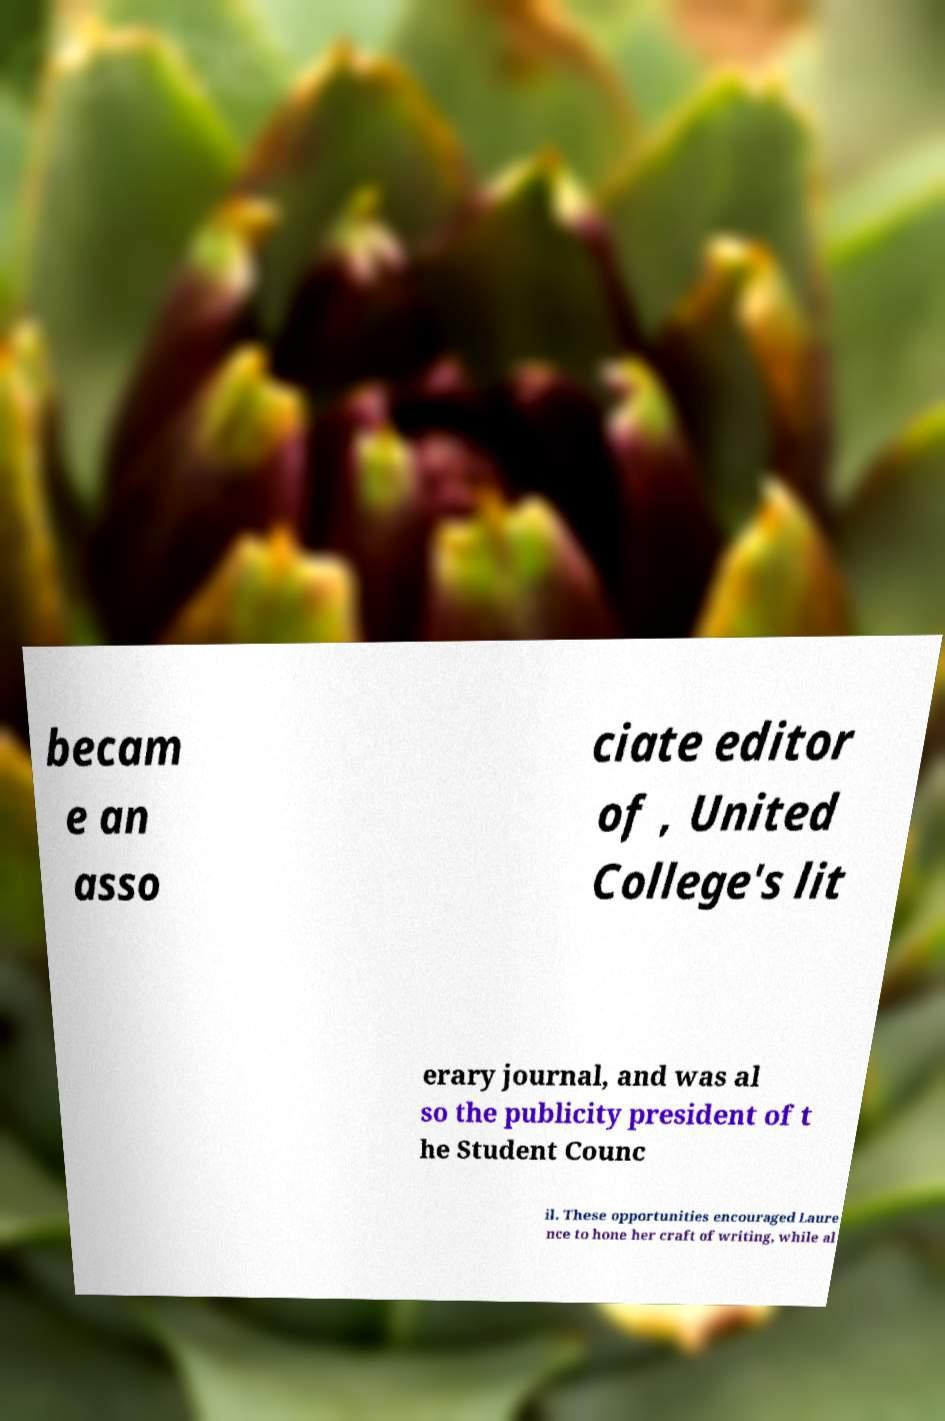For documentation purposes, I need the text within this image transcribed. Could you provide that? becam e an asso ciate editor of , United College's lit erary journal, and was al so the publicity president of t he Student Counc il. These opportunities encouraged Laure nce to hone her craft of writing, while al 